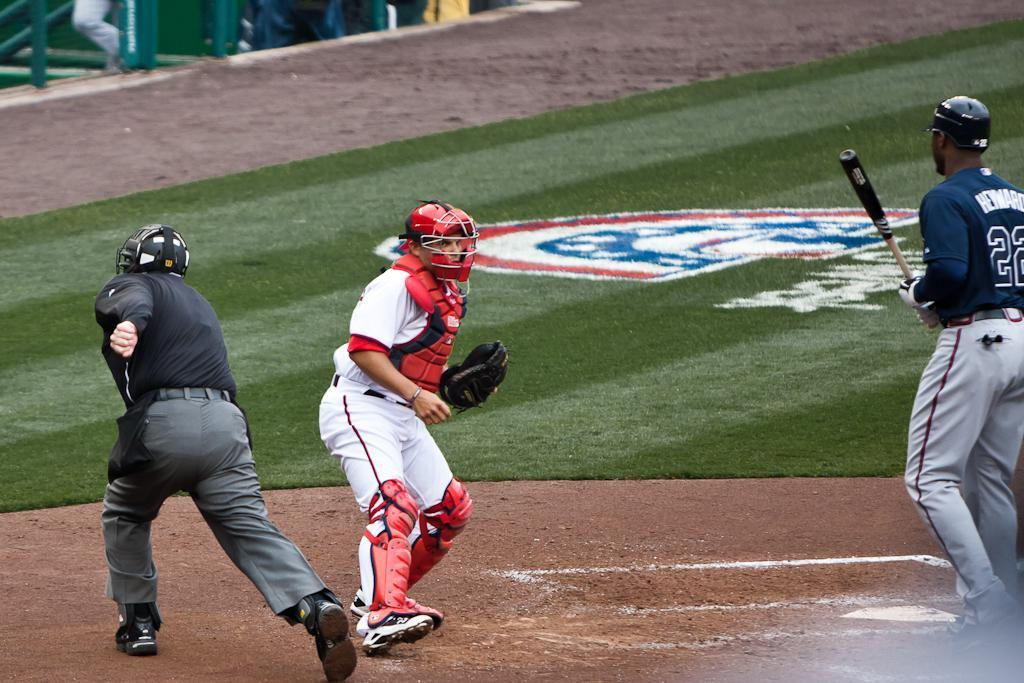<image>
Describe the image concisely. a player has Heyward on the back of a jersey 